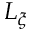Convert formula to latex. <formula><loc_0><loc_0><loc_500><loc_500>L _ { \xi }</formula> 